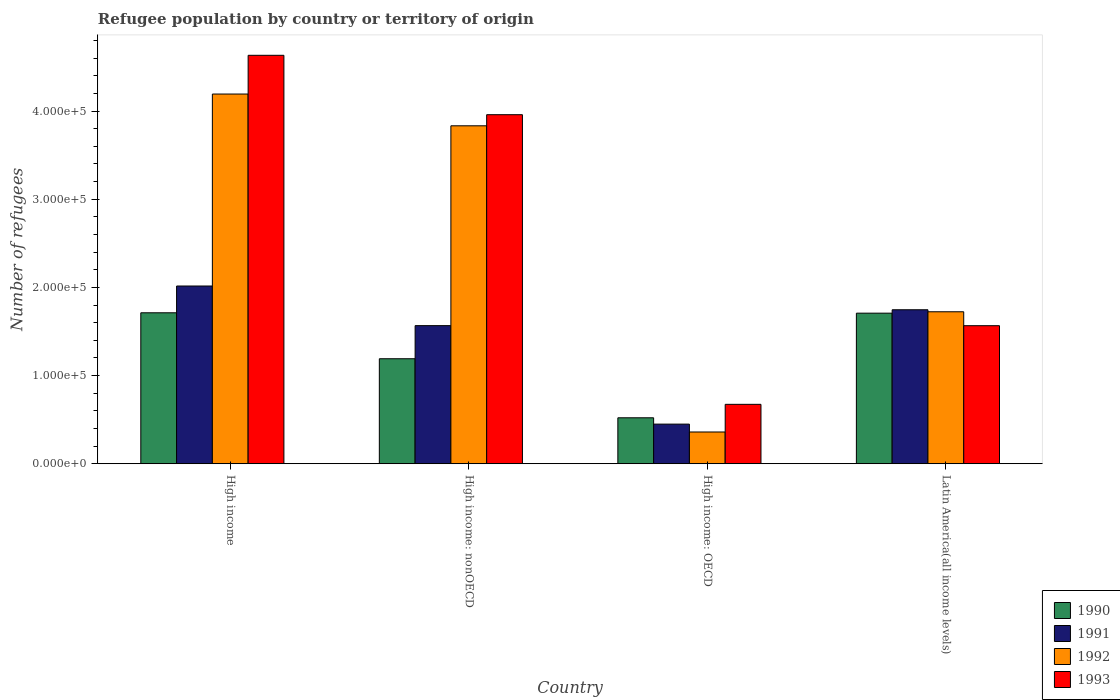How many different coloured bars are there?
Offer a terse response. 4. Are the number of bars per tick equal to the number of legend labels?
Keep it short and to the point. Yes. Are the number of bars on each tick of the X-axis equal?
Make the answer very short. Yes. What is the label of the 2nd group of bars from the left?
Offer a terse response. High income: nonOECD. In how many cases, is the number of bars for a given country not equal to the number of legend labels?
Keep it short and to the point. 0. What is the number of refugees in 1993 in High income?
Provide a short and direct response. 4.63e+05. Across all countries, what is the maximum number of refugees in 1991?
Offer a very short reply. 2.02e+05. Across all countries, what is the minimum number of refugees in 1991?
Your answer should be very brief. 4.49e+04. In which country was the number of refugees in 1991 minimum?
Keep it short and to the point. High income: OECD. What is the total number of refugees in 1990 in the graph?
Give a very brief answer. 5.13e+05. What is the difference between the number of refugees in 1990 in High income: nonOECD and that in Latin America(all income levels)?
Your answer should be compact. -5.17e+04. What is the difference between the number of refugees in 1991 in High income and the number of refugees in 1993 in Latin America(all income levels)?
Your answer should be very brief. 4.50e+04. What is the average number of refugees in 1992 per country?
Keep it short and to the point. 2.53e+05. What is the difference between the number of refugees of/in 1991 and number of refugees of/in 1993 in High income: nonOECD?
Your answer should be very brief. -2.39e+05. What is the ratio of the number of refugees in 1992 in High income: OECD to that in High income: nonOECD?
Give a very brief answer. 0.09. What is the difference between the highest and the second highest number of refugees in 1992?
Offer a terse response. -2.47e+05. What is the difference between the highest and the lowest number of refugees in 1990?
Offer a terse response. 1.19e+05. In how many countries, is the number of refugees in 1992 greater than the average number of refugees in 1992 taken over all countries?
Offer a terse response. 2. Is the sum of the number of refugees in 1990 in High income and Latin America(all income levels) greater than the maximum number of refugees in 1992 across all countries?
Give a very brief answer. No. Is it the case that in every country, the sum of the number of refugees in 1990 and number of refugees in 1993 is greater than the sum of number of refugees in 1991 and number of refugees in 1992?
Your answer should be compact. No. What does the 3rd bar from the left in High income: nonOECD represents?
Ensure brevity in your answer.  1992. Is it the case that in every country, the sum of the number of refugees in 1992 and number of refugees in 1993 is greater than the number of refugees in 1990?
Provide a succinct answer. Yes. How many bars are there?
Give a very brief answer. 16. Are the values on the major ticks of Y-axis written in scientific E-notation?
Your answer should be very brief. Yes. Does the graph contain any zero values?
Offer a terse response. No. How many legend labels are there?
Your answer should be very brief. 4. What is the title of the graph?
Provide a short and direct response. Refugee population by country or territory of origin. What is the label or title of the X-axis?
Provide a short and direct response. Country. What is the label or title of the Y-axis?
Offer a terse response. Number of refugees. What is the Number of refugees of 1990 in High income?
Offer a terse response. 1.71e+05. What is the Number of refugees in 1991 in High income?
Give a very brief answer. 2.02e+05. What is the Number of refugees of 1992 in High income?
Ensure brevity in your answer.  4.19e+05. What is the Number of refugees of 1993 in High income?
Your answer should be compact. 4.63e+05. What is the Number of refugees in 1990 in High income: nonOECD?
Your response must be concise. 1.19e+05. What is the Number of refugees in 1991 in High income: nonOECD?
Ensure brevity in your answer.  1.57e+05. What is the Number of refugees of 1992 in High income: nonOECD?
Your answer should be very brief. 3.83e+05. What is the Number of refugees in 1993 in High income: nonOECD?
Ensure brevity in your answer.  3.96e+05. What is the Number of refugees of 1990 in High income: OECD?
Ensure brevity in your answer.  5.21e+04. What is the Number of refugees of 1991 in High income: OECD?
Provide a short and direct response. 4.49e+04. What is the Number of refugees of 1992 in High income: OECD?
Offer a very short reply. 3.60e+04. What is the Number of refugees in 1993 in High income: OECD?
Keep it short and to the point. 6.74e+04. What is the Number of refugees of 1990 in Latin America(all income levels)?
Make the answer very short. 1.71e+05. What is the Number of refugees of 1991 in Latin America(all income levels)?
Your answer should be very brief. 1.75e+05. What is the Number of refugees of 1992 in Latin America(all income levels)?
Make the answer very short. 1.72e+05. What is the Number of refugees of 1993 in Latin America(all income levels)?
Give a very brief answer. 1.57e+05. Across all countries, what is the maximum Number of refugees in 1990?
Keep it short and to the point. 1.71e+05. Across all countries, what is the maximum Number of refugees in 1991?
Make the answer very short. 2.02e+05. Across all countries, what is the maximum Number of refugees in 1992?
Provide a short and direct response. 4.19e+05. Across all countries, what is the maximum Number of refugees in 1993?
Give a very brief answer. 4.63e+05. Across all countries, what is the minimum Number of refugees of 1990?
Ensure brevity in your answer.  5.21e+04. Across all countries, what is the minimum Number of refugees of 1991?
Make the answer very short. 4.49e+04. Across all countries, what is the minimum Number of refugees of 1992?
Give a very brief answer. 3.60e+04. Across all countries, what is the minimum Number of refugees of 1993?
Keep it short and to the point. 6.74e+04. What is the total Number of refugees in 1990 in the graph?
Offer a very short reply. 5.13e+05. What is the total Number of refugees in 1991 in the graph?
Provide a short and direct response. 5.78e+05. What is the total Number of refugees in 1992 in the graph?
Give a very brief answer. 1.01e+06. What is the total Number of refugees of 1993 in the graph?
Provide a short and direct response. 1.08e+06. What is the difference between the Number of refugees in 1990 in High income and that in High income: nonOECD?
Provide a short and direct response. 5.21e+04. What is the difference between the Number of refugees of 1991 in High income and that in High income: nonOECD?
Offer a very short reply. 4.49e+04. What is the difference between the Number of refugees in 1992 in High income and that in High income: nonOECD?
Offer a terse response. 3.60e+04. What is the difference between the Number of refugees of 1993 in High income and that in High income: nonOECD?
Make the answer very short. 6.74e+04. What is the difference between the Number of refugees in 1990 in High income and that in High income: OECD?
Your answer should be compact. 1.19e+05. What is the difference between the Number of refugees of 1991 in High income and that in High income: OECD?
Make the answer very short. 1.57e+05. What is the difference between the Number of refugees of 1992 in High income and that in High income: OECD?
Ensure brevity in your answer.  3.83e+05. What is the difference between the Number of refugees of 1993 in High income and that in High income: OECD?
Keep it short and to the point. 3.96e+05. What is the difference between the Number of refugees of 1990 in High income and that in Latin America(all income levels)?
Provide a succinct answer. 421. What is the difference between the Number of refugees in 1991 in High income and that in Latin America(all income levels)?
Your answer should be very brief. 2.69e+04. What is the difference between the Number of refugees of 1992 in High income and that in Latin America(all income levels)?
Offer a terse response. 2.47e+05. What is the difference between the Number of refugees in 1993 in High income and that in Latin America(all income levels)?
Provide a short and direct response. 3.07e+05. What is the difference between the Number of refugees in 1990 in High income: nonOECD and that in High income: OECD?
Provide a short and direct response. 6.70e+04. What is the difference between the Number of refugees of 1991 in High income: nonOECD and that in High income: OECD?
Make the answer very short. 1.12e+05. What is the difference between the Number of refugees in 1992 in High income: nonOECD and that in High income: OECD?
Offer a terse response. 3.47e+05. What is the difference between the Number of refugees in 1993 in High income: nonOECD and that in High income: OECD?
Provide a short and direct response. 3.28e+05. What is the difference between the Number of refugees in 1990 in High income: nonOECD and that in Latin America(all income levels)?
Keep it short and to the point. -5.17e+04. What is the difference between the Number of refugees of 1991 in High income: nonOECD and that in Latin America(all income levels)?
Ensure brevity in your answer.  -1.80e+04. What is the difference between the Number of refugees of 1992 in High income: nonOECD and that in Latin America(all income levels)?
Keep it short and to the point. 2.11e+05. What is the difference between the Number of refugees in 1993 in High income: nonOECD and that in Latin America(all income levels)?
Give a very brief answer. 2.39e+05. What is the difference between the Number of refugees of 1990 in High income: OECD and that in Latin America(all income levels)?
Provide a succinct answer. -1.19e+05. What is the difference between the Number of refugees in 1991 in High income: OECD and that in Latin America(all income levels)?
Your answer should be compact. -1.30e+05. What is the difference between the Number of refugees of 1992 in High income: OECD and that in Latin America(all income levels)?
Offer a terse response. -1.36e+05. What is the difference between the Number of refugees of 1993 in High income: OECD and that in Latin America(all income levels)?
Give a very brief answer. -8.92e+04. What is the difference between the Number of refugees in 1990 in High income and the Number of refugees in 1991 in High income: nonOECD?
Give a very brief answer. 1.46e+04. What is the difference between the Number of refugees in 1990 in High income and the Number of refugees in 1992 in High income: nonOECD?
Make the answer very short. -2.12e+05. What is the difference between the Number of refugees of 1990 in High income and the Number of refugees of 1993 in High income: nonOECD?
Ensure brevity in your answer.  -2.25e+05. What is the difference between the Number of refugees in 1991 in High income and the Number of refugees in 1992 in High income: nonOECD?
Your answer should be compact. -1.82e+05. What is the difference between the Number of refugees of 1991 in High income and the Number of refugees of 1993 in High income: nonOECD?
Offer a terse response. -1.94e+05. What is the difference between the Number of refugees of 1992 in High income and the Number of refugees of 1993 in High income: nonOECD?
Ensure brevity in your answer.  2.34e+04. What is the difference between the Number of refugees in 1990 in High income and the Number of refugees in 1991 in High income: OECD?
Your answer should be very brief. 1.26e+05. What is the difference between the Number of refugees in 1990 in High income and the Number of refugees in 1992 in High income: OECD?
Ensure brevity in your answer.  1.35e+05. What is the difference between the Number of refugees of 1990 in High income and the Number of refugees of 1993 in High income: OECD?
Ensure brevity in your answer.  1.04e+05. What is the difference between the Number of refugees of 1991 in High income and the Number of refugees of 1992 in High income: OECD?
Provide a short and direct response. 1.66e+05. What is the difference between the Number of refugees of 1991 in High income and the Number of refugees of 1993 in High income: OECD?
Provide a succinct answer. 1.34e+05. What is the difference between the Number of refugees of 1992 in High income and the Number of refugees of 1993 in High income: OECD?
Your answer should be compact. 3.52e+05. What is the difference between the Number of refugees of 1990 in High income and the Number of refugees of 1991 in Latin America(all income levels)?
Keep it short and to the point. -3446. What is the difference between the Number of refugees in 1990 in High income and the Number of refugees in 1992 in Latin America(all income levels)?
Your answer should be very brief. -1148. What is the difference between the Number of refugees of 1990 in High income and the Number of refugees of 1993 in Latin America(all income levels)?
Offer a very short reply. 1.46e+04. What is the difference between the Number of refugees in 1991 in High income and the Number of refugees in 1992 in Latin America(all income levels)?
Your response must be concise. 2.92e+04. What is the difference between the Number of refugees in 1991 in High income and the Number of refugees in 1993 in Latin America(all income levels)?
Ensure brevity in your answer.  4.50e+04. What is the difference between the Number of refugees of 1992 in High income and the Number of refugees of 1993 in Latin America(all income levels)?
Make the answer very short. 2.63e+05. What is the difference between the Number of refugees in 1990 in High income: nonOECD and the Number of refugees in 1991 in High income: OECD?
Offer a very short reply. 7.41e+04. What is the difference between the Number of refugees in 1990 in High income: nonOECD and the Number of refugees in 1992 in High income: OECD?
Give a very brief answer. 8.31e+04. What is the difference between the Number of refugees in 1990 in High income: nonOECD and the Number of refugees in 1993 in High income: OECD?
Keep it short and to the point. 5.17e+04. What is the difference between the Number of refugees in 1991 in High income: nonOECD and the Number of refugees in 1992 in High income: OECD?
Provide a succinct answer. 1.21e+05. What is the difference between the Number of refugees of 1991 in High income: nonOECD and the Number of refugees of 1993 in High income: OECD?
Your answer should be very brief. 8.92e+04. What is the difference between the Number of refugees of 1992 in High income: nonOECD and the Number of refugees of 1993 in High income: OECD?
Provide a succinct answer. 3.16e+05. What is the difference between the Number of refugees in 1990 in High income: nonOECD and the Number of refugees in 1991 in Latin America(all income levels)?
Provide a short and direct response. -5.56e+04. What is the difference between the Number of refugees in 1990 in High income: nonOECD and the Number of refugees in 1992 in Latin America(all income levels)?
Provide a succinct answer. -5.33e+04. What is the difference between the Number of refugees of 1990 in High income: nonOECD and the Number of refugees of 1993 in Latin America(all income levels)?
Ensure brevity in your answer.  -3.75e+04. What is the difference between the Number of refugees of 1991 in High income: nonOECD and the Number of refugees of 1992 in Latin America(all income levels)?
Keep it short and to the point. -1.57e+04. What is the difference between the Number of refugees in 1991 in High income: nonOECD and the Number of refugees in 1993 in Latin America(all income levels)?
Your answer should be compact. 75. What is the difference between the Number of refugees in 1992 in High income: nonOECD and the Number of refugees in 1993 in Latin America(all income levels)?
Offer a terse response. 2.27e+05. What is the difference between the Number of refugees in 1990 in High income: OECD and the Number of refugees in 1991 in Latin America(all income levels)?
Make the answer very short. -1.23e+05. What is the difference between the Number of refugees in 1990 in High income: OECD and the Number of refugees in 1992 in Latin America(all income levels)?
Your answer should be compact. -1.20e+05. What is the difference between the Number of refugees of 1990 in High income: OECD and the Number of refugees of 1993 in Latin America(all income levels)?
Make the answer very short. -1.04e+05. What is the difference between the Number of refugees in 1991 in High income: OECD and the Number of refugees in 1992 in Latin America(all income levels)?
Provide a short and direct response. -1.27e+05. What is the difference between the Number of refugees in 1991 in High income: OECD and the Number of refugees in 1993 in Latin America(all income levels)?
Give a very brief answer. -1.12e+05. What is the difference between the Number of refugees in 1992 in High income: OECD and the Number of refugees in 1993 in Latin America(all income levels)?
Offer a terse response. -1.21e+05. What is the average Number of refugees in 1990 per country?
Offer a terse response. 1.28e+05. What is the average Number of refugees of 1991 per country?
Offer a terse response. 1.44e+05. What is the average Number of refugees of 1992 per country?
Ensure brevity in your answer.  2.53e+05. What is the average Number of refugees of 1993 per country?
Your answer should be compact. 2.71e+05. What is the difference between the Number of refugees in 1990 and Number of refugees in 1991 in High income?
Keep it short and to the point. -3.04e+04. What is the difference between the Number of refugees of 1990 and Number of refugees of 1992 in High income?
Keep it short and to the point. -2.48e+05. What is the difference between the Number of refugees in 1990 and Number of refugees in 1993 in High income?
Give a very brief answer. -2.92e+05. What is the difference between the Number of refugees in 1991 and Number of refugees in 1992 in High income?
Your response must be concise. -2.18e+05. What is the difference between the Number of refugees in 1991 and Number of refugees in 1993 in High income?
Give a very brief answer. -2.62e+05. What is the difference between the Number of refugees in 1992 and Number of refugees in 1993 in High income?
Give a very brief answer. -4.39e+04. What is the difference between the Number of refugees in 1990 and Number of refugees in 1991 in High income: nonOECD?
Offer a very short reply. -3.75e+04. What is the difference between the Number of refugees in 1990 and Number of refugees in 1992 in High income: nonOECD?
Your response must be concise. -2.64e+05. What is the difference between the Number of refugees in 1990 and Number of refugees in 1993 in High income: nonOECD?
Offer a very short reply. -2.77e+05. What is the difference between the Number of refugees in 1991 and Number of refugees in 1992 in High income: nonOECD?
Provide a short and direct response. -2.27e+05. What is the difference between the Number of refugees in 1991 and Number of refugees in 1993 in High income: nonOECD?
Your answer should be compact. -2.39e+05. What is the difference between the Number of refugees of 1992 and Number of refugees of 1993 in High income: nonOECD?
Make the answer very short. -1.26e+04. What is the difference between the Number of refugees of 1990 and Number of refugees of 1991 in High income: OECD?
Your answer should be compact. 7172. What is the difference between the Number of refugees of 1990 and Number of refugees of 1992 in High income: OECD?
Ensure brevity in your answer.  1.61e+04. What is the difference between the Number of refugees in 1990 and Number of refugees in 1993 in High income: OECD?
Make the answer very short. -1.53e+04. What is the difference between the Number of refugees of 1991 and Number of refugees of 1992 in High income: OECD?
Provide a short and direct response. 8926. What is the difference between the Number of refugees in 1991 and Number of refugees in 1993 in High income: OECD?
Provide a succinct answer. -2.24e+04. What is the difference between the Number of refugees of 1992 and Number of refugees of 1993 in High income: OECD?
Your response must be concise. -3.14e+04. What is the difference between the Number of refugees of 1990 and Number of refugees of 1991 in Latin America(all income levels)?
Your answer should be very brief. -3867. What is the difference between the Number of refugees in 1990 and Number of refugees in 1992 in Latin America(all income levels)?
Your answer should be very brief. -1569. What is the difference between the Number of refugees in 1990 and Number of refugees in 1993 in Latin America(all income levels)?
Offer a terse response. 1.42e+04. What is the difference between the Number of refugees of 1991 and Number of refugees of 1992 in Latin America(all income levels)?
Your answer should be very brief. 2298. What is the difference between the Number of refugees in 1991 and Number of refugees in 1993 in Latin America(all income levels)?
Ensure brevity in your answer.  1.81e+04. What is the difference between the Number of refugees in 1992 and Number of refugees in 1993 in Latin America(all income levels)?
Provide a short and direct response. 1.58e+04. What is the ratio of the Number of refugees of 1990 in High income to that in High income: nonOECD?
Ensure brevity in your answer.  1.44. What is the ratio of the Number of refugees of 1991 in High income to that in High income: nonOECD?
Give a very brief answer. 1.29. What is the ratio of the Number of refugees of 1992 in High income to that in High income: nonOECD?
Offer a very short reply. 1.09. What is the ratio of the Number of refugees in 1993 in High income to that in High income: nonOECD?
Provide a short and direct response. 1.17. What is the ratio of the Number of refugees of 1990 in High income to that in High income: OECD?
Make the answer very short. 3.29. What is the ratio of the Number of refugees in 1991 in High income to that in High income: OECD?
Offer a terse response. 4.49. What is the ratio of the Number of refugees in 1992 in High income to that in High income: OECD?
Keep it short and to the point. 11.64. What is the ratio of the Number of refugees in 1993 in High income to that in High income: OECD?
Your response must be concise. 6.88. What is the ratio of the Number of refugees in 1991 in High income to that in Latin America(all income levels)?
Provide a short and direct response. 1.15. What is the ratio of the Number of refugees in 1992 in High income to that in Latin America(all income levels)?
Offer a terse response. 2.43. What is the ratio of the Number of refugees in 1993 in High income to that in Latin America(all income levels)?
Keep it short and to the point. 2.96. What is the ratio of the Number of refugees of 1990 in High income: nonOECD to that in High income: OECD?
Keep it short and to the point. 2.29. What is the ratio of the Number of refugees of 1991 in High income: nonOECD to that in High income: OECD?
Offer a very short reply. 3.49. What is the ratio of the Number of refugees of 1992 in High income: nonOECD to that in High income: OECD?
Give a very brief answer. 10.64. What is the ratio of the Number of refugees in 1993 in High income: nonOECD to that in High income: OECD?
Make the answer very short. 5.88. What is the ratio of the Number of refugees of 1990 in High income: nonOECD to that in Latin America(all income levels)?
Ensure brevity in your answer.  0.7. What is the ratio of the Number of refugees in 1991 in High income: nonOECD to that in Latin America(all income levels)?
Provide a short and direct response. 0.9. What is the ratio of the Number of refugees of 1992 in High income: nonOECD to that in Latin America(all income levels)?
Offer a terse response. 2.22. What is the ratio of the Number of refugees in 1993 in High income: nonOECD to that in Latin America(all income levels)?
Give a very brief answer. 2.53. What is the ratio of the Number of refugees of 1990 in High income: OECD to that in Latin America(all income levels)?
Offer a terse response. 0.31. What is the ratio of the Number of refugees of 1991 in High income: OECD to that in Latin America(all income levels)?
Give a very brief answer. 0.26. What is the ratio of the Number of refugees of 1992 in High income: OECD to that in Latin America(all income levels)?
Provide a short and direct response. 0.21. What is the ratio of the Number of refugees in 1993 in High income: OECD to that in Latin America(all income levels)?
Your answer should be compact. 0.43. What is the difference between the highest and the second highest Number of refugees in 1990?
Your answer should be very brief. 421. What is the difference between the highest and the second highest Number of refugees in 1991?
Offer a terse response. 2.69e+04. What is the difference between the highest and the second highest Number of refugees in 1992?
Ensure brevity in your answer.  3.60e+04. What is the difference between the highest and the second highest Number of refugees in 1993?
Give a very brief answer. 6.74e+04. What is the difference between the highest and the lowest Number of refugees of 1990?
Make the answer very short. 1.19e+05. What is the difference between the highest and the lowest Number of refugees in 1991?
Provide a short and direct response. 1.57e+05. What is the difference between the highest and the lowest Number of refugees in 1992?
Ensure brevity in your answer.  3.83e+05. What is the difference between the highest and the lowest Number of refugees in 1993?
Your answer should be very brief. 3.96e+05. 